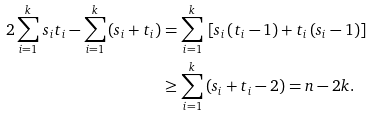Convert formula to latex. <formula><loc_0><loc_0><loc_500><loc_500>2 \sum _ { i = 1 } ^ { k } \, s _ { i } t _ { i } - \sum _ { i = 1 } ^ { k } \, ( s _ { i } + t _ { i } ) & = \sum _ { i = 1 } ^ { k } \, \left [ s _ { i } \, ( t _ { i } - 1 ) + t _ { i } \, ( s _ { i } - 1 ) \right ] \\ & \geq \sum _ { i = 1 } ^ { k } \, ( s _ { i } + t _ { i } - 2 ) = n - 2 k .</formula> 